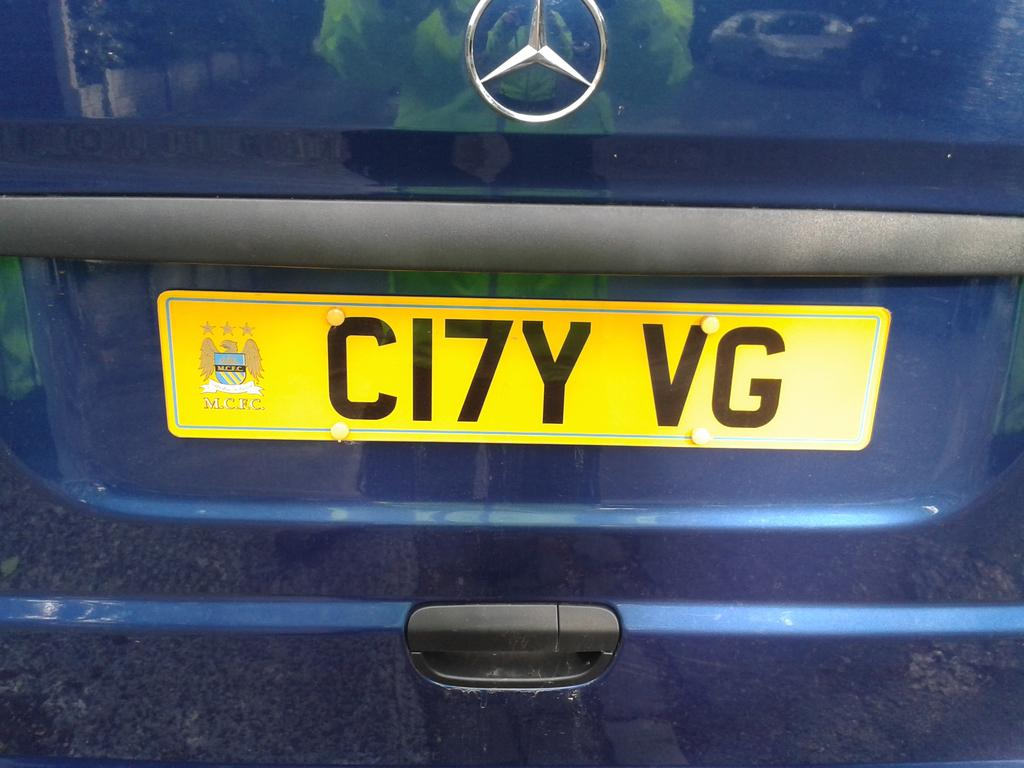Provide a one-sentence caption for the provided image. A Mercedes van has a yellow licence plate that says CI7Y VG. 